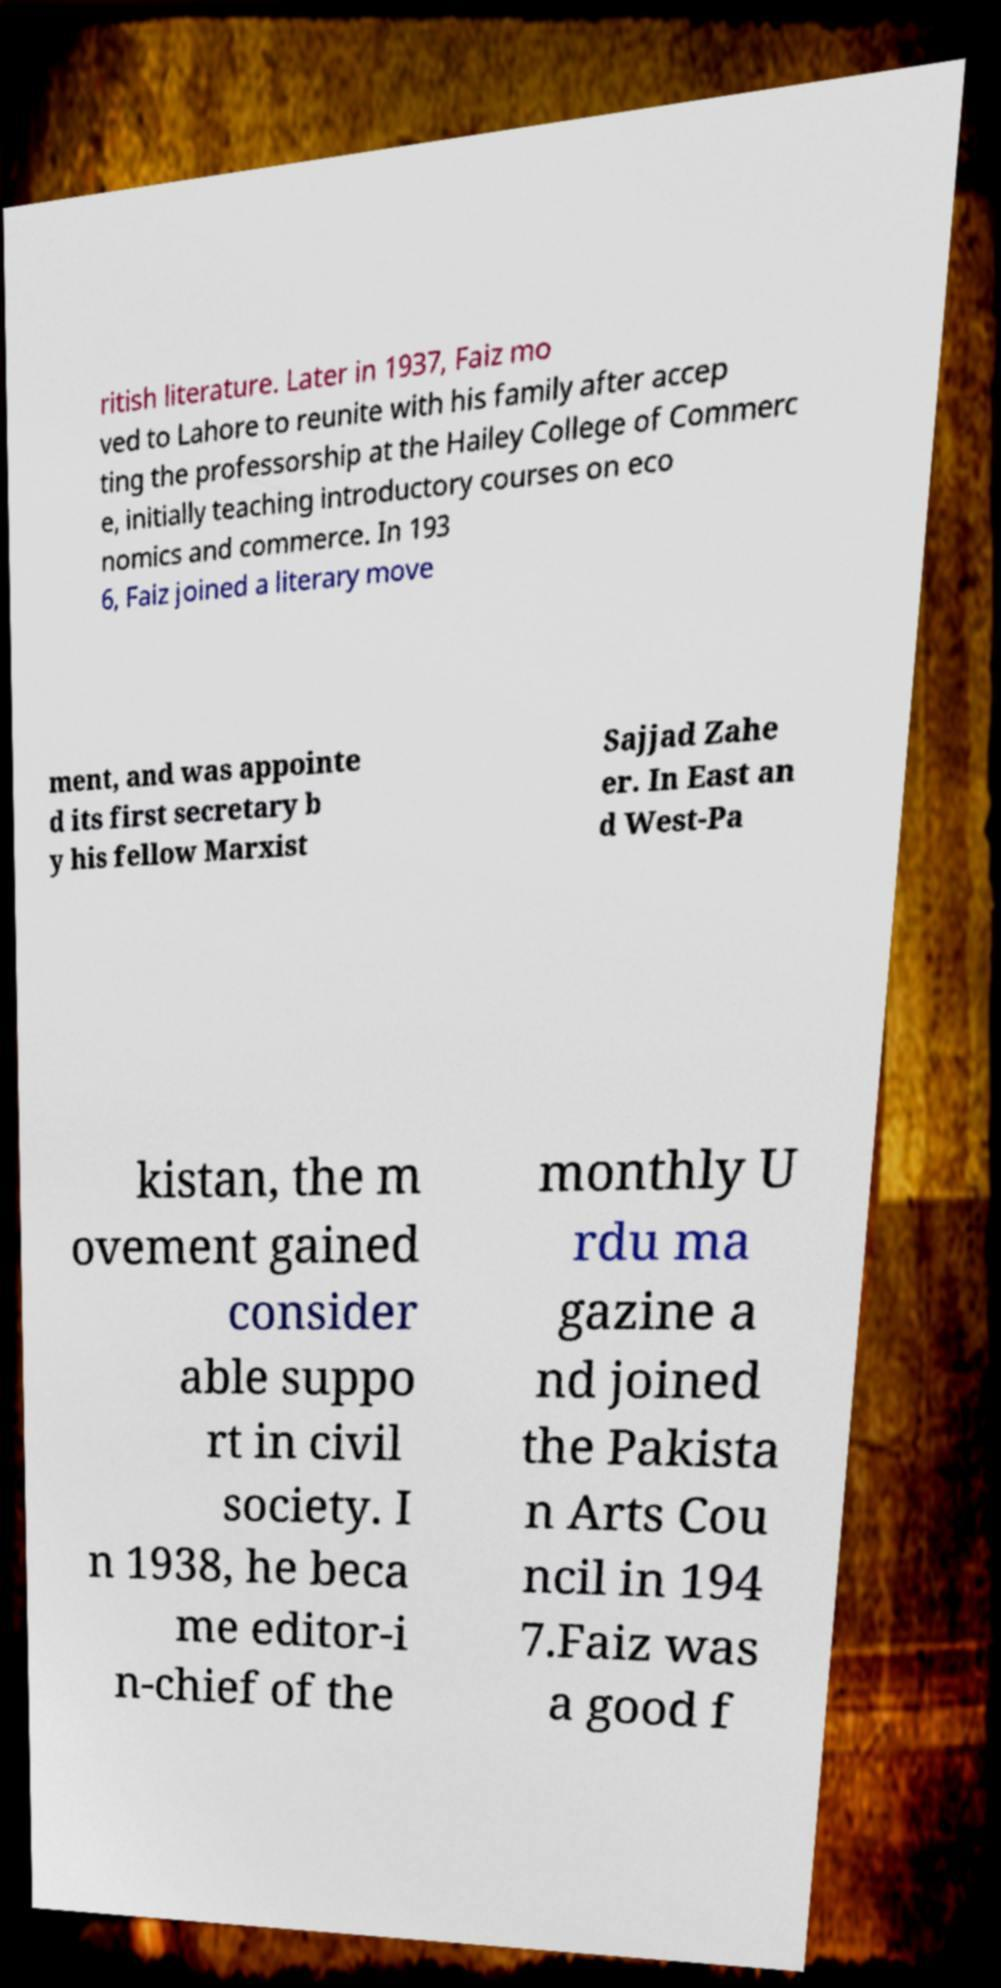Please read and relay the text visible in this image. What does it say? ritish literature. Later in 1937, Faiz mo ved to Lahore to reunite with his family after accep ting the professorship at the Hailey College of Commerc e, initially teaching introductory courses on eco nomics and commerce. In 193 6, Faiz joined a literary move ment, and was appointe d its first secretary b y his fellow Marxist Sajjad Zahe er. In East an d West-Pa kistan, the m ovement gained consider able suppo rt in civil society. I n 1938, he beca me editor-i n-chief of the monthly U rdu ma gazine a nd joined the Pakista n Arts Cou ncil in 194 7.Faiz was a good f 